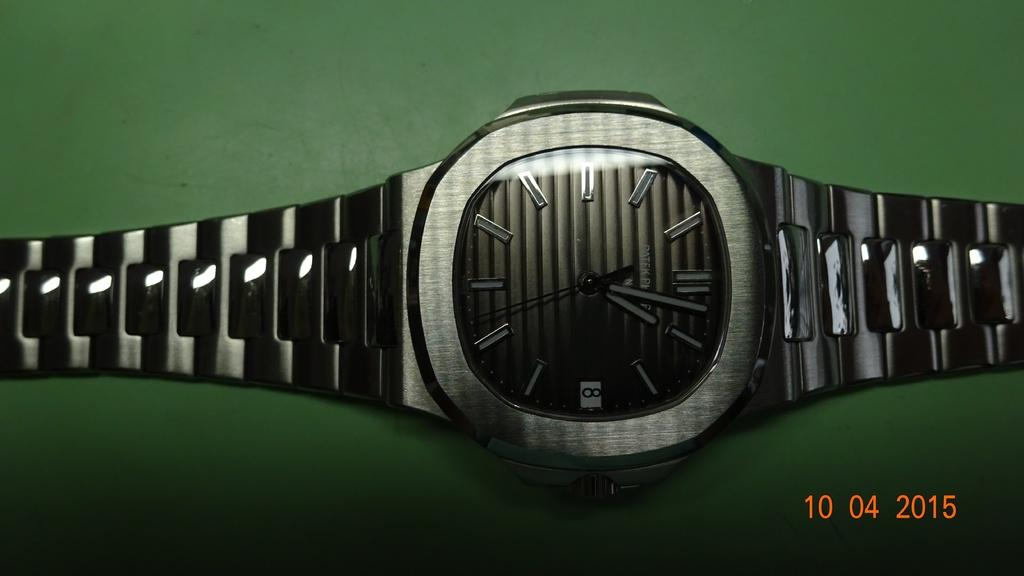<image>
Create a compact narrative representing the image presented. An all-black watch says that today is the 8th of the month. 